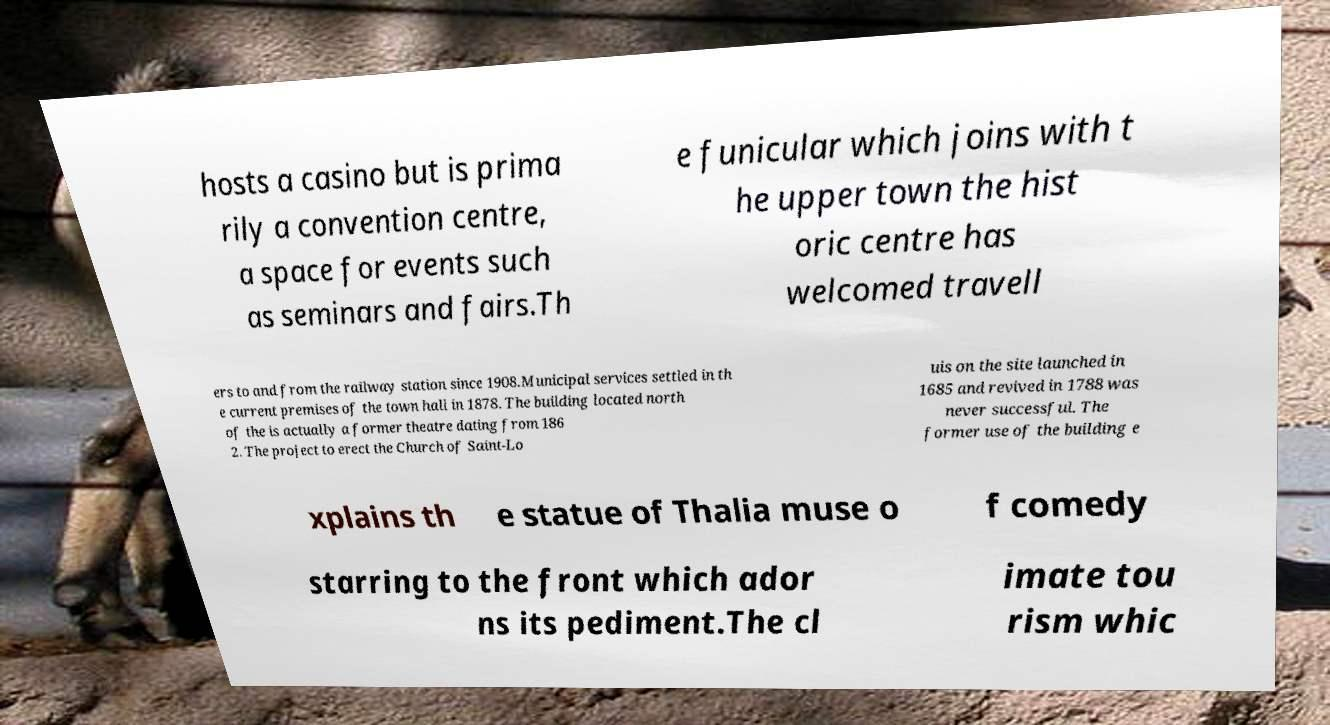Could you extract and type out the text from this image? hosts a casino but is prima rily a convention centre, a space for events such as seminars and fairs.Th e funicular which joins with t he upper town the hist oric centre has welcomed travell ers to and from the railway station since 1908.Municipal services settled in th e current premises of the town hall in 1878. The building located north of the is actually a former theatre dating from 186 2. The project to erect the Church of Saint-Lo uis on the site launched in 1685 and revived in 1788 was never successful. The former use of the building e xplains th e statue of Thalia muse o f comedy starring to the front which ador ns its pediment.The cl imate tou rism whic 